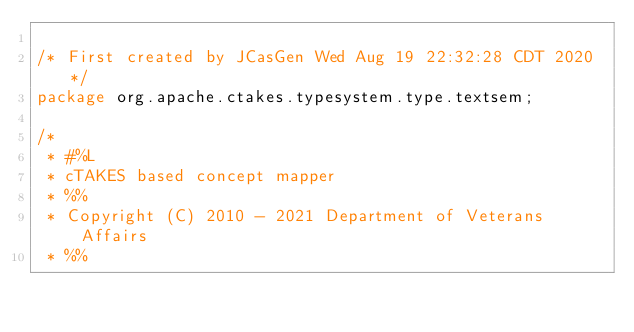<code> <loc_0><loc_0><loc_500><loc_500><_Java_>
/* First created by JCasGen Wed Aug 19 22:32:28 CDT 2020 */
package org.apache.ctakes.typesystem.type.textsem;

/*
 * #%L
 * cTAKES based concept mapper
 * %%
 * Copyright (C) 2010 - 2021 Department of Veterans Affairs
 * %%</code> 